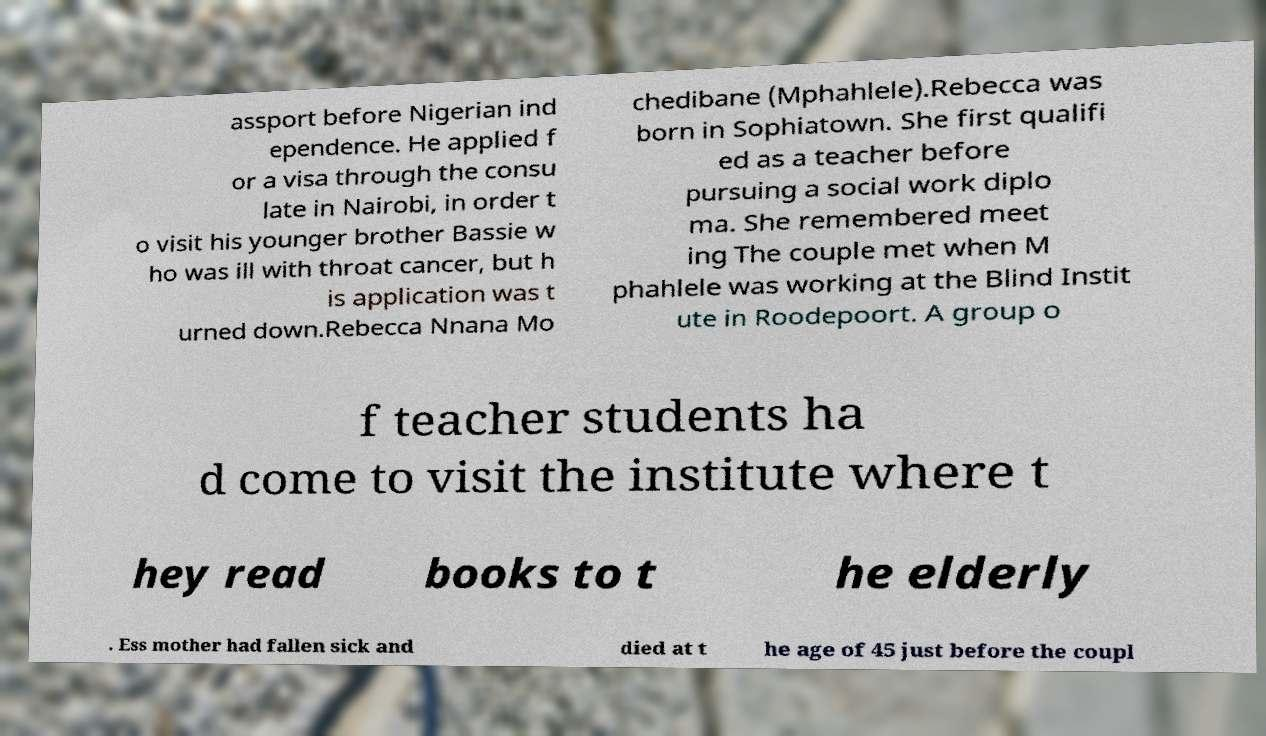I need the written content from this picture converted into text. Can you do that? assport before Nigerian ind ependence. He applied f or a visa through the consu late in Nairobi, in order t o visit his younger brother Bassie w ho was ill with throat cancer, but h is application was t urned down.Rebecca Nnana Mo chedibane (Mphahlele).Rebecca was born in Sophiatown. She first qualifi ed as a teacher before pursuing a social work diplo ma. She remembered meet ing The couple met when M phahlele was working at the Blind Instit ute in Roodepoort. A group o f teacher students ha d come to visit the institute where t hey read books to t he elderly . Ess mother had fallen sick and died at t he age of 45 just before the coupl 